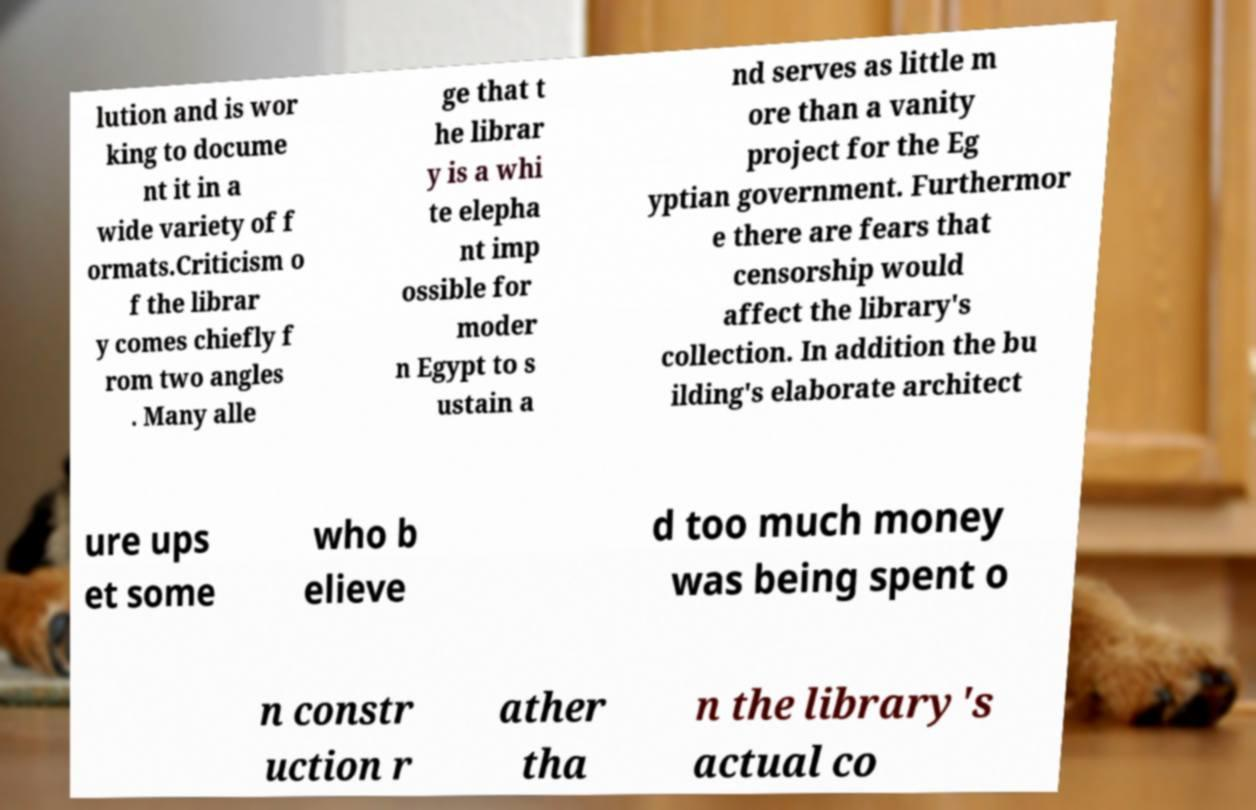There's text embedded in this image that I need extracted. Can you transcribe it verbatim? lution and is wor king to docume nt it in a wide variety of f ormats.Criticism o f the librar y comes chiefly f rom two angles . Many alle ge that t he librar y is a whi te elepha nt imp ossible for moder n Egypt to s ustain a nd serves as little m ore than a vanity project for the Eg yptian government. Furthermor e there are fears that censorship would affect the library's collection. In addition the bu ilding's elaborate architect ure ups et some who b elieve d too much money was being spent o n constr uction r ather tha n the library's actual co 